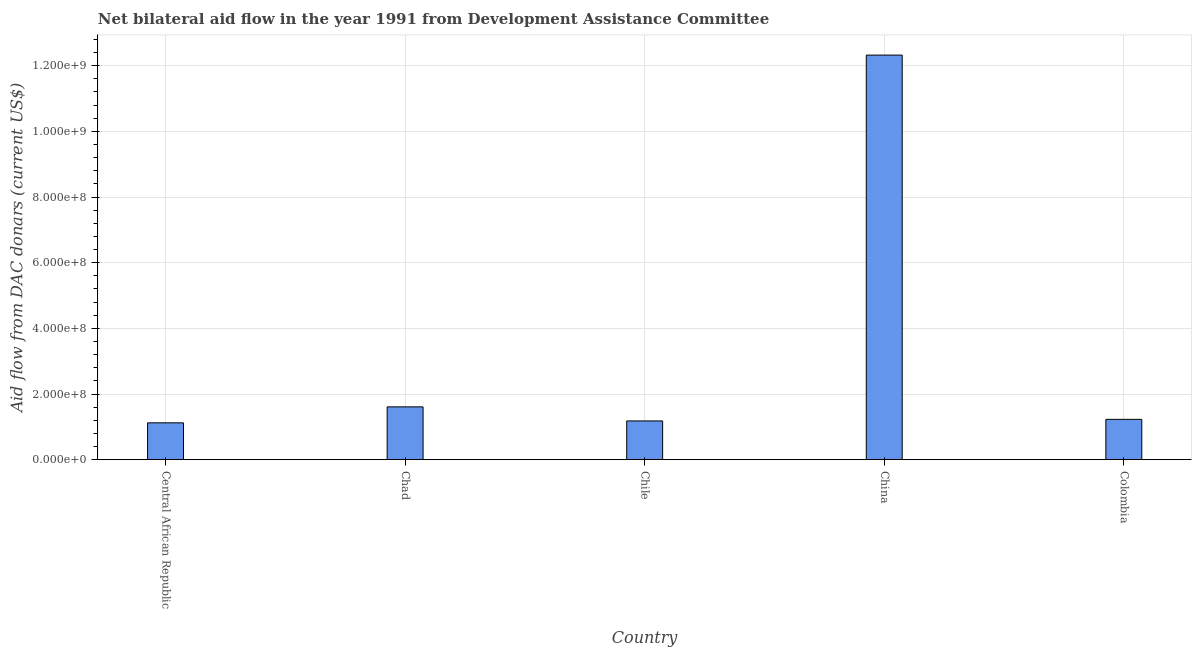What is the title of the graph?
Provide a short and direct response. Net bilateral aid flow in the year 1991 from Development Assistance Committee. What is the label or title of the X-axis?
Offer a terse response. Country. What is the label or title of the Y-axis?
Offer a very short reply. Aid flow from DAC donars (current US$). What is the net bilateral aid flows from dac donors in Central African Republic?
Offer a terse response. 1.12e+08. Across all countries, what is the maximum net bilateral aid flows from dac donors?
Keep it short and to the point. 1.23e+09. Across all countries, what is the minimum net bilateral aid flows from dac donors?
Your answer should be compact. 1.12e+08. In which country was the net bilateral aid flows from dac donors maximum?
Ensure brevity in your answer.  China. In which country was the net bilateral aid flows from dac donors minimum?
Your response must be concise. Central African Republic. What is the sum of the net bilateral aid flows from dac donors?
Ensure brevity in your answer.  1.75e+09. What is the difference between the net bilateral aid flows from dac donors in Chad and Chile?
Provide a short and direct response. 4.28e+07. What is the average net bilateral aid flows from dac donors per country?
Ensure brevity in your answer.  3.49e+08. What is the median net bilateral aid flows from dac donors?
Make the answer very short. 1.23e+08. In how many countries, is the net bilateral aid flows from dac donors greater than 720000000 US$?
Provide a short and direct response. 1. What is the ratio of the net bilateral aid flows from dac donors in Chad to that in Colombia?
Provide a succinct answer. 1.31. Is the net bilateral aid flows from dac donors in Chile less than that in Colombia?
Your response must be concise. Yes. What is the difference between the highest and the second highest net bilateral aid flows from dac donors?
Give a very brief answer. 1.07e+09. Is the sum of the net bilateral aid flows from dac donors in Chile and China greater than the maximum net bilateral aid flows from dac donors across all countries?
Provide a succinct answer. Yes. What is the difference between the highest and the lowest net bilateral aid flows from dac donors?
Provide a succinct answer. 1.12e+09. How many bars are there?
Your response must be concise. 5. Are all the bars in the graph horizontal?
Offer a terse response. No. Are the values on the major ticks of Y-axis written in scientific E-notation?
Provide a short and direct response. Yes. What is the Aid flow from DAC donars (current US$) of Central African Republic?
Provide a short and direct response. 1.12e+08. What is the Aid flow from DAC donars (current US$) in Chad?
Offer a terse response. 1.61e+08. What is the Aid flow from DAC donars (current US$) of Chile?
Provide a succinct answer. 1.18e+08. What is the Aid flow from DAC donars (current US$) in China?
Provide a short and direct response. 1.23e+09. What is the Aid flow from DAC donars (current US$) in Colombia?
Keep it short and to the point. 1.23e+08. What is the difference between the Aid flow from DAC donars (current US$) in Central African Republic and Chad?
Provide a succinct answer. -4.86e+07. What is the difference between the Aid flow from DAC donars (current US$) in Central African Republic and Chile?
Keep it short and to the point. -5.84e+06. What is the difference between the Aid flow from DAC donars (current US$) in Central African Republic and China?
Provide a short and direct response. -1.12e+09. What is the difference between the Aid flow from DAC donars (current US$) in Central African Republic and Colombia?
Your answer should be compact. -1.06e+07. What is the difference between the Aid flow from DAC donars (current US$) in Chad and Chile?
Offer a very short reply. 4.28e+07. What is the difference between the Aid flow from DAC donars (current US$) in Chad and China?
Your answer should be very brief. -1.07e+09. What is the difference between the Aid flow from DAC donars (current US$) in Chad and Colombia?
Ensure brevity in your answer.  3.80e+07. What is the difference between the Aid flow from DAC donars (current US$) in Chile and China?
Give a very brief answer. -1.11e+09. What is the difference between the Aid flow from DAC donars (current US$) in Chile and Colombia?
Offer a very short reply. -4.78e+06. What is the difference between the Aid flow from DAC donars (current US$) in China and Colombia?
Keep it short and to the point. 1.11e+09. What is the ratio of the Aid flow from DAC donars (current US$) in Central African Republic to that in Chad?
Offer a terse response. 0.7. What is the ratio of the Aid flow from DAC donars (current US$) in Central African Republic to that in Chile?
Your answer should be compact. 0.95. What is the ratio of the Aid flow from DAC donars (current US$) in Central African Republic to that in China?
Make the answer very short. 0.09. What is the ratio of the Aid flow from DAC donars (current US$) in Central African Republic to that in Colombia?
Provide a succinct answer. 0.91. What is the ratio of the Aid flow from DAC donars (current US$) in Chad to that in Chile?
Offer a terse response. 1.36. What is the ratio of the Aid flow from DAC donars (current US$) in Chad to that in China?
Your answer should be very brief. 0.13. What is the ratio of the Aid flow from DAC donars (current US$) in Chad to that in Colombia?
Keep it short and to the point. 1.31. What is the ratio of the Aid flow from DAC donars (current US$) in Chile to that in China?
Your answer should be compact. 0.1. What is the ratio of the Aid flow from DAC donars (current US$) in Chile to that in Colombia?
Provide a short and direct response. 0.96. What is the ratio of the Aid flow from DAC donars (current US$) in China to that in Colombia?
Ensure brevity in your answer.  10.03. 